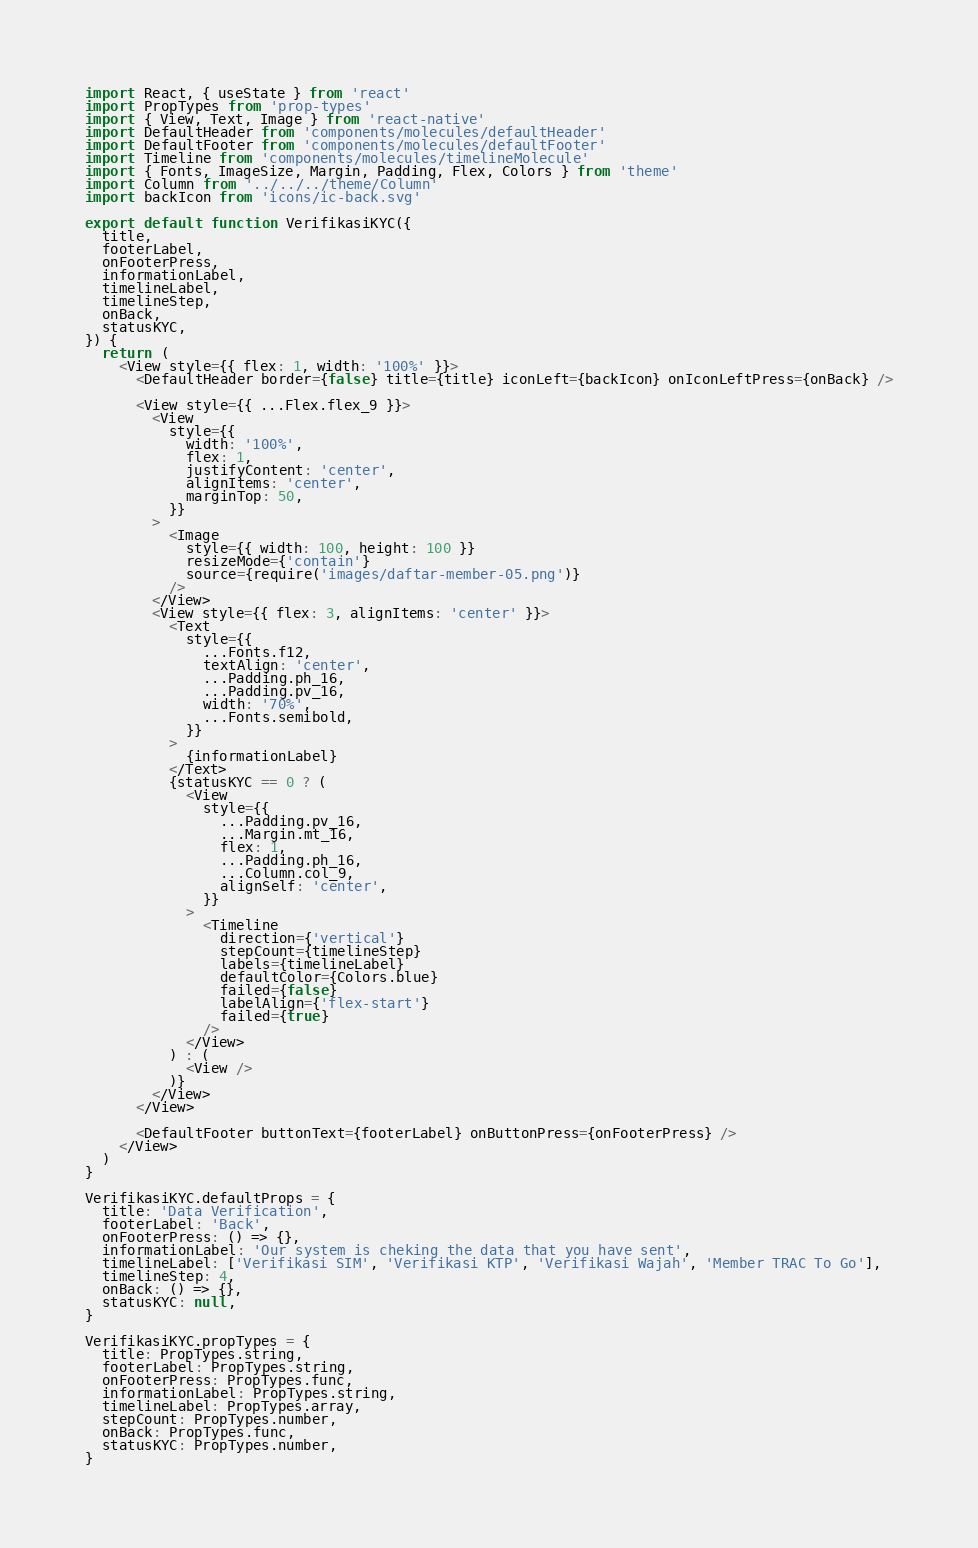Convert code to text. <code><loc_0><loc_0><loc_500><loc_500><_JavaScript_>import React, { useState } from 'react'
import PropTypes from 'prop-types'
import { View, Text, Image } from 'react-native'
import DefaultHeader from 'components/molecules/defaultHeader'
import DefaultFooter from 'components/molecules/defaultFooter'
import Timeline from 'components/molecules/timelineMolecule'
import { Fonts, ImageSize, Margin, Padding, Flex, Colors } from 'theme'
import Column from '../../../theme/Column'
import backIcon from 'icons/ic-back.svg'

export default function VerifikasiKYC({
  title,
  footerLabel,
  onFooterPress,
  informationLabel,
  timelineLabel,
  timelineStep,
  onBack,
  statusKYC,
}) {
  return (
    <View style={{ flex: 1, width: '100%' }}>
      <DefaultHeader border={false} title={title} iconLeft={backIcon} onIconLeftPress={onBack} />

      <View style={{ ...Flex.flex_9 }}>
        <View
          style={{
            width: '100%',
            flex: 1,
            justifyContent: 'center',
            alignItems: 'center',
            marginTop: 50,
          }}
        >
          <Image
            style={{ width: 100, height: 100 }}
            resizeMode={'contain'}
            source={require('images/daftar-member-05.png')}
          />
        </View>
        <View style={{ flex: 3, alignItems: 'center' }}>
          <Text
            style={{
              ...Fonts.f12,
              textAlign: 'center',
              ...Padding.ph_16,
              ...Padding.pv_16,
              width: '70%',
              ...Fonts.semibold,
            }}
          >
            {informationLabel}
          </Text>
          {statusKYC == 0 ? (
            <View
              style={{
                ...Padding.pv_16,
                ...Margin.mt_16,
                flex: 1,
                ...Padding.ph_16,
                ...Column.col_9,
                alignSelf: 'center',
              }}
            >
              <Timeline
                direction={'vertical'}
                stepCount={timelineStep}
                labels={timelineLabel}
                defaultColor={Colors.blue}
                failed={false}
                labelAlign={'flex-start'}
                failed={true}
              />
            </View>
          ) : (
            <View />
          )}
        </View>
      </View>

      <DefaultFooter buttonText={footerLabel} onButtonPress={onFooterPress} />
    </View>
  )
}

VerifikasiKYC.defaultProps = {
  title: 'Data Verification',
  footerLabel: 'Back',
  onFooterPress: () => {},
  informationLabel: 'Our system is cheking the data that you have sent',
  timelineLabel: ['Verifikasi SIM', 'Verifikasi KTP', 'Verifikasi Wajah', 'Member TRAC To Go'],
  timelineStep: 4,
  onBack: () => {},
  statusKYC: null,
}

VerifikasiKYC.propTypes = {
  title: PropTypes.string,
  footerLabel: PropTypes.string,
  onFooterPress: PropTypes.func,
  informationLabel: PropTypes.string,
  timelineLabel: PropTypes.array,
  stepCount: PropTypes.number,
  onBack: PropTypes.func,
  statusKYC: PropTypes.number,
}
</code> 